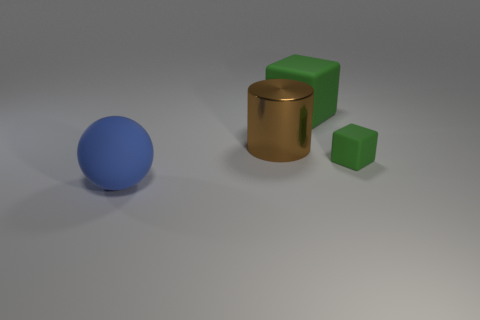Are there any objects that reflect light like a mirror? None of the objects in the image exhibit mirror-like reflections; they all have diffusely reflective surfaces with soft shadows, indicating a matte finish. 